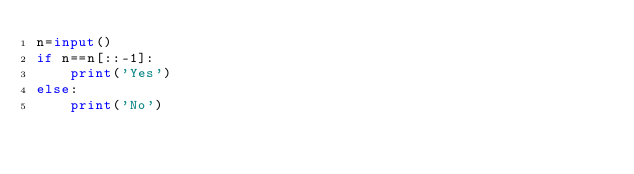<code> <loc_0><loc_0><loc_500><loc_500><_Python_>n=input()
if n==n[::-1]:
    print('Yes')
else:
    print('No')</code> 